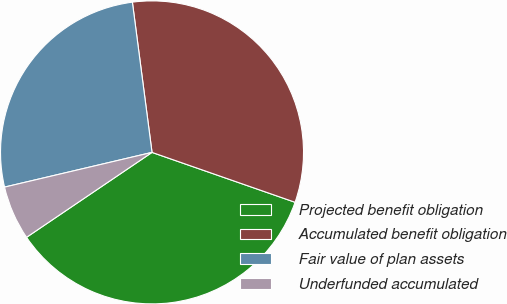Convert chart. <chart><loc_0><loc_0><loc_500><loc_500><pie_chart><fcel>Projected benefit obligation<fcel>Accumulated benefit obligation<fcel>Fair value of plan assets<fcel>Underfunded accumulated<nl><fcel>35.19%<fcel>32.41%<fcel>26.61%<fcel>5.79%<nl></chart> 